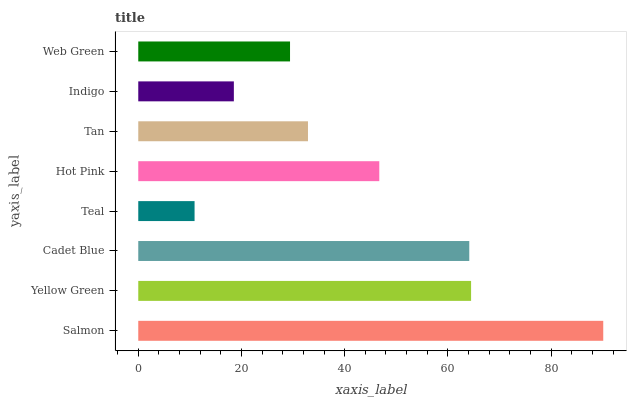Is Teal the minimum?
Answer yes or no. Yes. Is Salmon the maximum?
Answer yes or no. Yes. Is Yellow Green the minimum?
Answer yes or no. No. Is Yellow Green the maximum?
Answer yes or no. No. Is Salmon greater than Yellow Green?
Answer yes or no. Yes. Is Yellow Green less than Salmon?
Answer yes or no. Yes. Is Yellow Green greater than Salmon?
Answer yes or no. No. Is Salmon less than Yellow Green?
Answer yes or no. No. Is Hot Pink the high median?
Answer yes or no. Yes. Is Tan the low median?
Answer yes or no. Yes. Is Yellow Green the high median?
Answer yes or no. No. Is Salmon the low median?
Answer yes or no. No. 